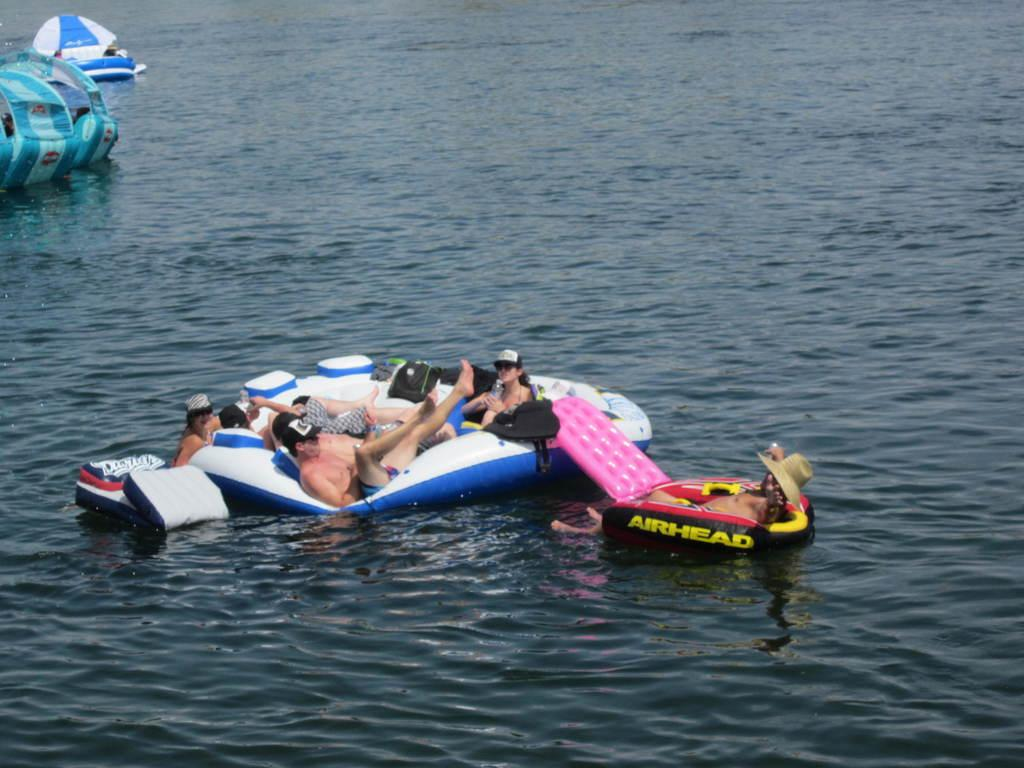<image>
Offer a succinct explanation of the picture presented. Someone floats in a raft that says airhead on the side. 